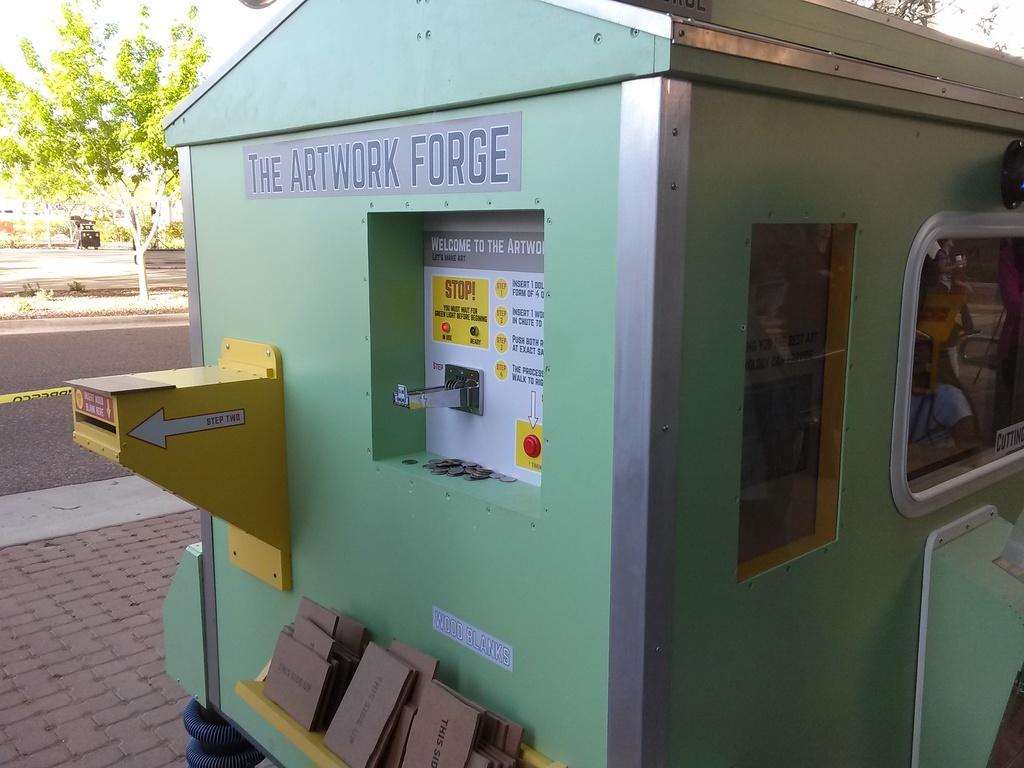<image>
Offer a succinct explanation of the picture presented. A green building called The Artwork Forge is along a street. 